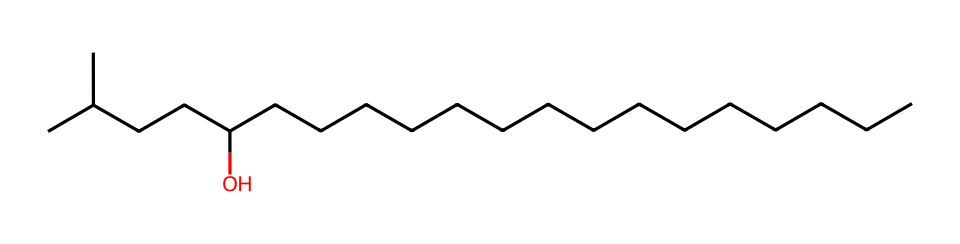What is the primary functional group present in this molecule? The structure contains an -OH group, indicating it has a hydroxyl functional group. This can be identified by looking at the oxygen atom attached to a hydrogen atom in the long carbon chain.
Answer: hydroxyl How many carbon atoms are in this chemical structure? By counting the carbon atoms in the SMILES notation, we see there are 21 carbon atoms represented by the letter 'C'. Each 'C' corresponds to a carbon atom in the structure.
Answer: 21 What type of lipid does this structure represent? This chemical is a fatty alcohol, indicated by the long carbon chain and the hydroxyl group at the end. Fatty alcohols are characterized by this specific structure, making them a type of lipid.
Answer: fatty alcohol How many branches are present in the carbon chain? In the provided structure, there are two branching points, indicated by the two locations where smaller carbon chains are attached to the main carbon chain. Each branch represents a side group off the primary chain.
Answer: 2 Is this compound saturated or unsaturated? The absence of double or triple bonds in the carbon chain suggests that this compound is saturated, allowing it to only have single bonds connecting the carbon atoms.
Answer: saturated What is the significance of the hydroxyl group in this lipid? The hydroxyl group contributes to the hydrophilic property of this lipid, which is important for attracting moisture, thus making it effective in lip balms for vocal care. This hydrophilic nature can enhance its moisturizing capabilities.
Answer: moisture-attracting 